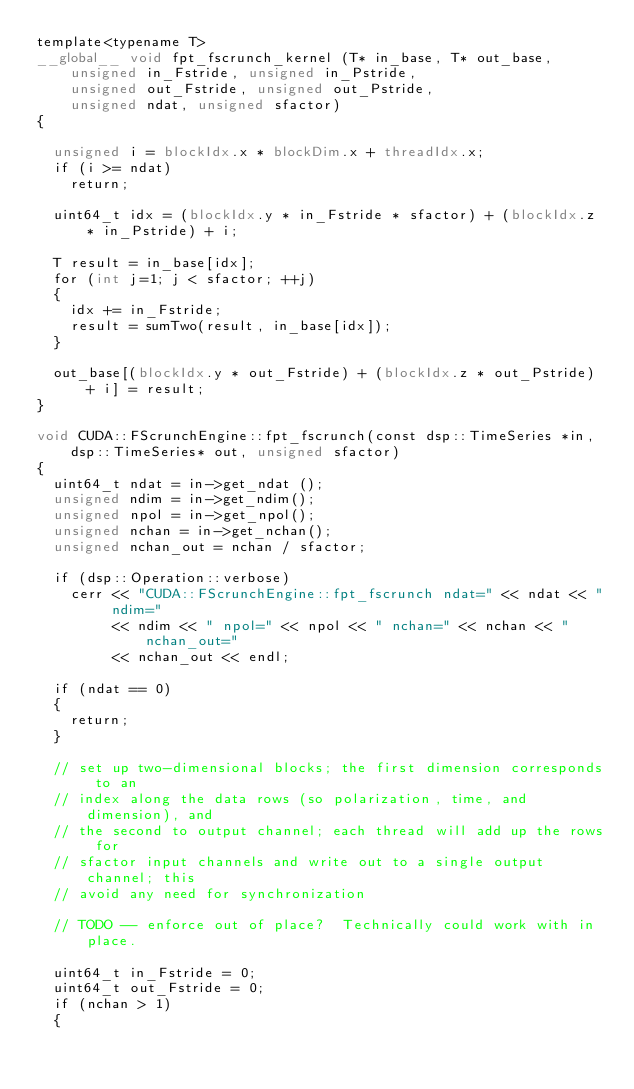<code> <loc_0><loc_0><loc_500><loc_500><_Cuda_>template<typename T>
__global__ void fpt_fscrunch_kernel (T* in_base, T* out_base,
    unsigned in_Fstride, unsigned in_Pstride,
    unsigned out_Fstride, unsigned out_Pstride,
    unsigned ndat, unsigned sfactor)
{

  unsigned i = blockIdx.x * blockDim.x + threadIdx.x;
  if (i >= ndat)
    return;

  uint64_t idx = (blockIdx.y * in_Fstride * sfactor) + (blockIdx.z * in_Pstride) + i;

  T result = in_base[idx];
  for (int j=1; j < sfactor; ++j)
  {
    idx += in_Fstride;
    result = sumTwo(result, in_base[idx]);
  }

  out_base[(blockIdx.y * out_Fstride) + (blockIdx.z * out_Pstride) + i] = result;
}

void CUDA::FScrunchEngine::fpt_fscrunch(const dsp::TimeSeries *in,
    dsp::TimeSeries* out, unsigned sfactor)
{
  uint64_t ndat = in->get_ndat ();
  unsigned ndim = in->get_ndim();
  unsigned npol = in->get_npol();
  unsigned nchan = in->get_nchan();
  unsigned nchan_out = nchan / sfactor;

  if (dsp::Operation::verbose)
    cerr << "CUDA::FScrunchEngine::fpt_fscrunch ndat=" << ndat << " ndim=" 
         << ndim << " npol=" << npol << " nchan=" << nchan << " nchan_out="
         << nchan_out << endl;

  if (ndat == 0)
  {
    return;
  }

  // set up two-dimensional blocks; the first dimension corresponds to an
  // index along the data rows (so polarization, time, and dimension), and
  // the second to output channel; each thread will add up the rows for
  // sfactor input channels and write out to a single output channel; this
  // avoid any need for synchronization

  // TODO -- enforce out of place?  Technically could work with in place.

  uint64_t in_Fstride = 0;
  uint64_t out_Fstride = 0;
  if (nchan > 1)
  {</code> 